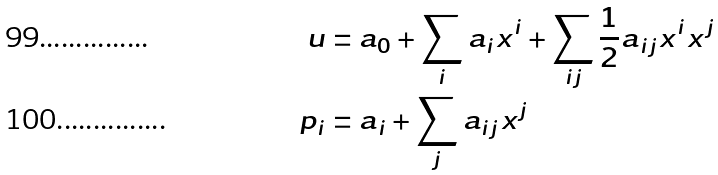<formula> <loc_0><loc_0><loc_500><loc_500>u & = a _ { 0 } + \sum _ { i } a _ { i } x ^ { i } + \sum _ { i j } \frac { 1 } { 2 } a _ { i j } x ^ { i } x ^ { j } \\ p _ { i } & = a _ { i } + \sum _ { j } a _ { i j } x ^ { j }</formula> 